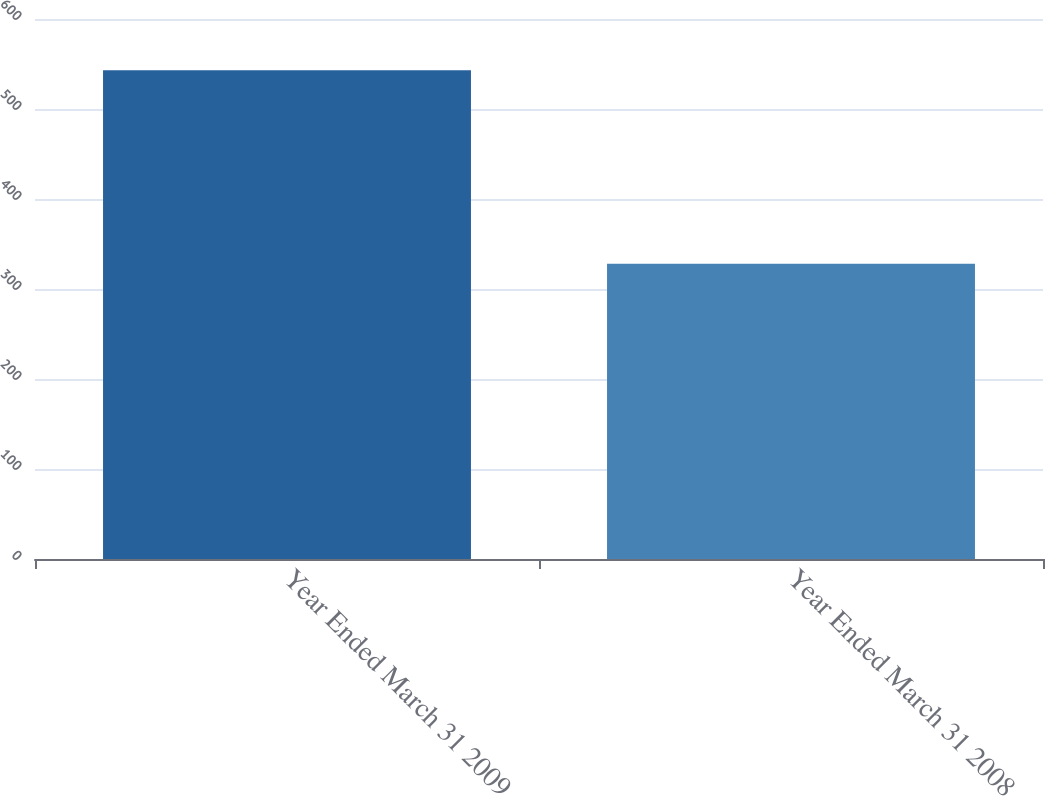<chart> <loc_0><loc_0><loc_500><loc_500><bar_chart><fcel>Year Ended March 31 2009<fcel>Year Ended March 31 2008<nl><fcel>543<fcel>328<nl></chart> 